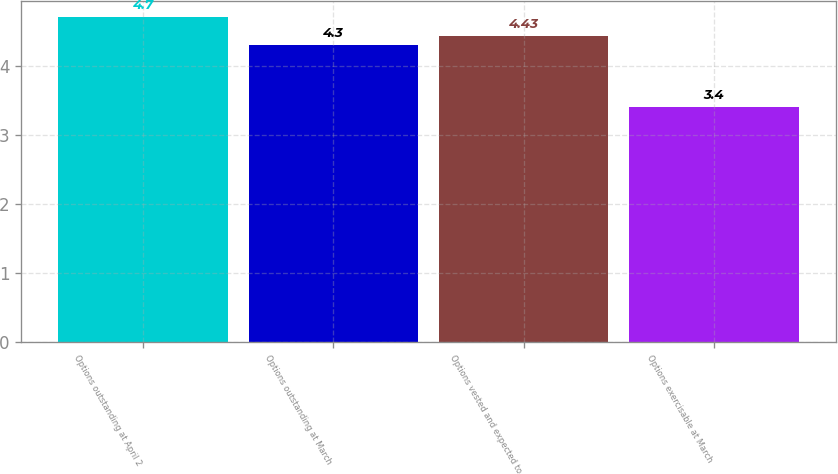Convert chart. <chart><loc_0><loc_0><loc_500><loc_500><bar_chart><fcel>Options outstanding at April 2<fcel>Options outstanding at March<fcel>Options vested and expected to<fcel>Options exercisable at March<nl><fcel>4.7<fcel>4.3<fcel>4.43<fcel>3.4<nl></chart> 